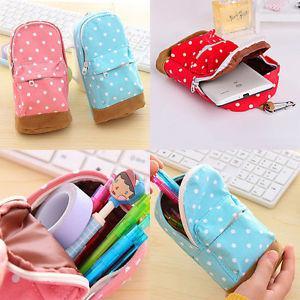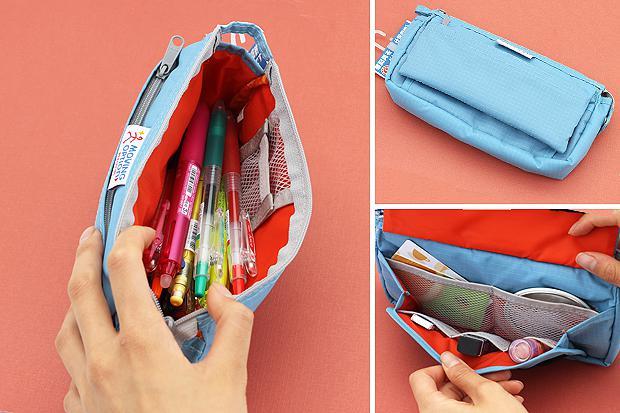The first image is the image on the left, the second image is the image on the right. For the images displayed, is the sentence "A hand is opening a pencil case in the right image." factually correct? Answer yes or no. Yes. 